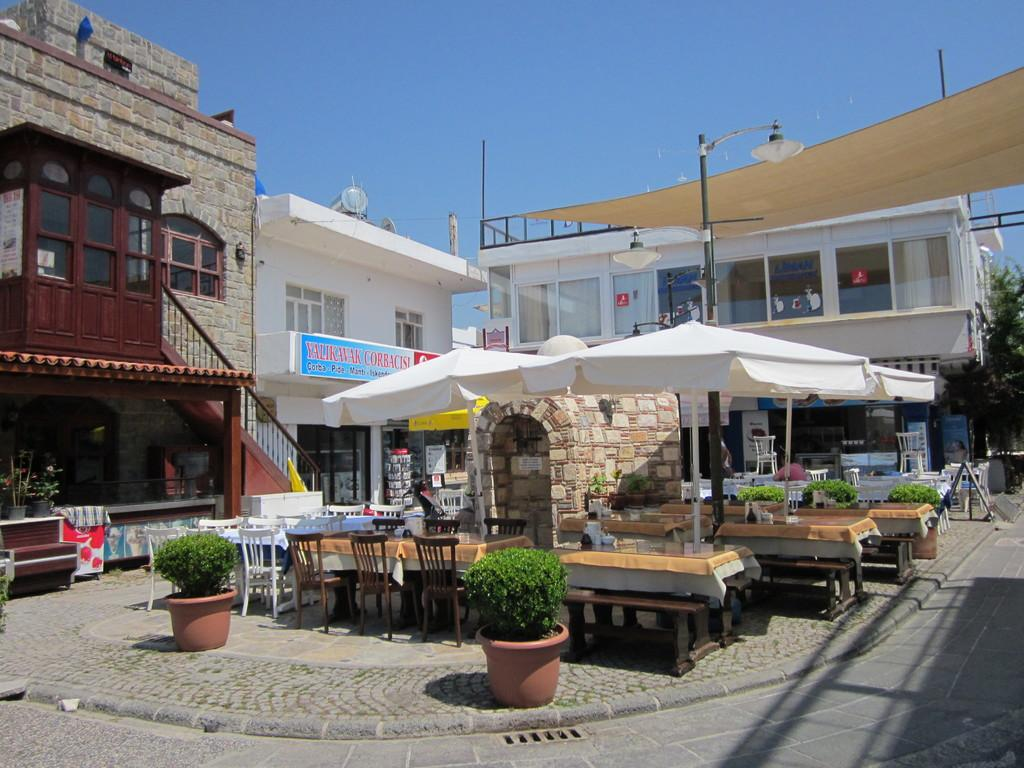What type of structures can be seen in the image? There are buildings in the image. What type of furniture is present in the image? There are tables and chairs in the image. What type of object is used for shade in the image? There is an umbrella in the image. How many crows are sitting on the baseball in the image? There is no baseball or crow present in the image. What shape is the square in the image? There is no square present in the image. 